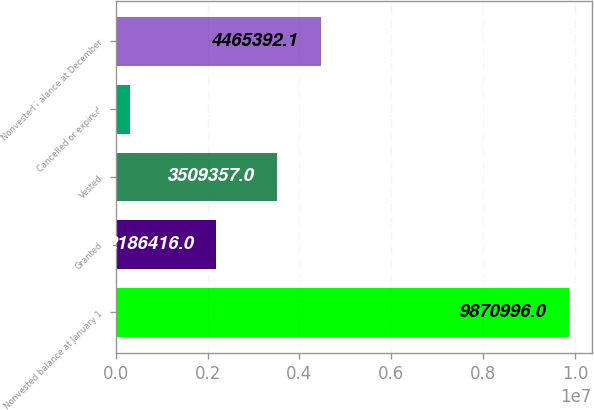<chart> <loc_0><loc_0><loc_500><loc_500><bar_chart><fcel>Nonvested balance at January 1<fcel>Granted<fcel>Vested<fcel>Cancelled or expired<fcel>Nonvested balance at December<nl><fcel>9.871e+06<fcel>2.18642e+06<fcel>3.50936e+06<fcel>310645<fcel>4.46539e+06<nl></chart> 